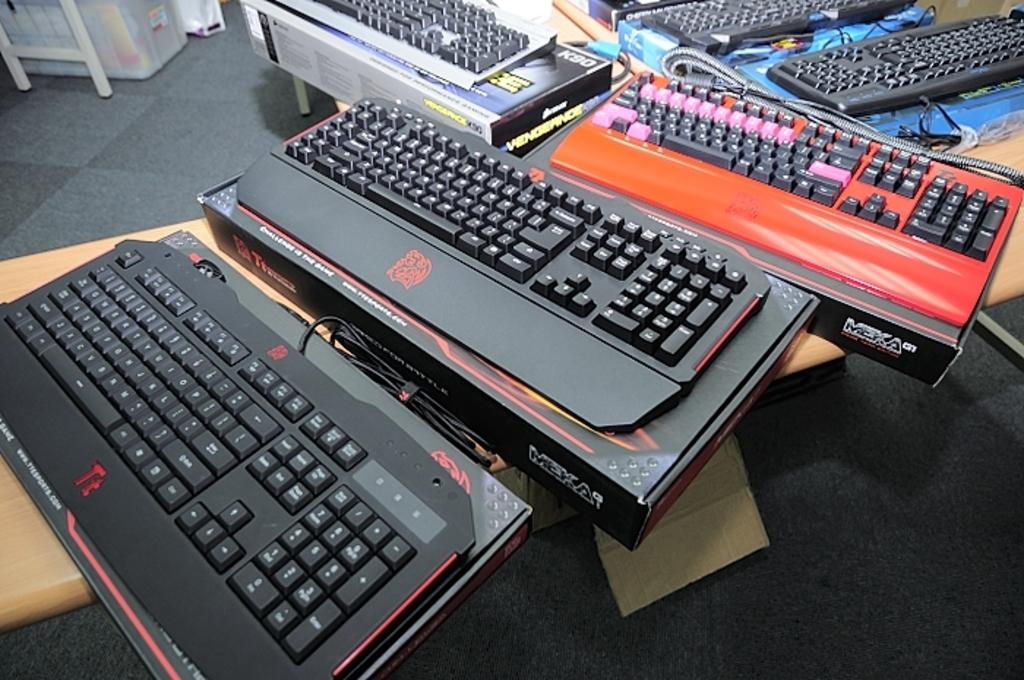<image>
Give a short and clear explanation of the subsequent image. Several Meka brand keyboards sit on a table. 